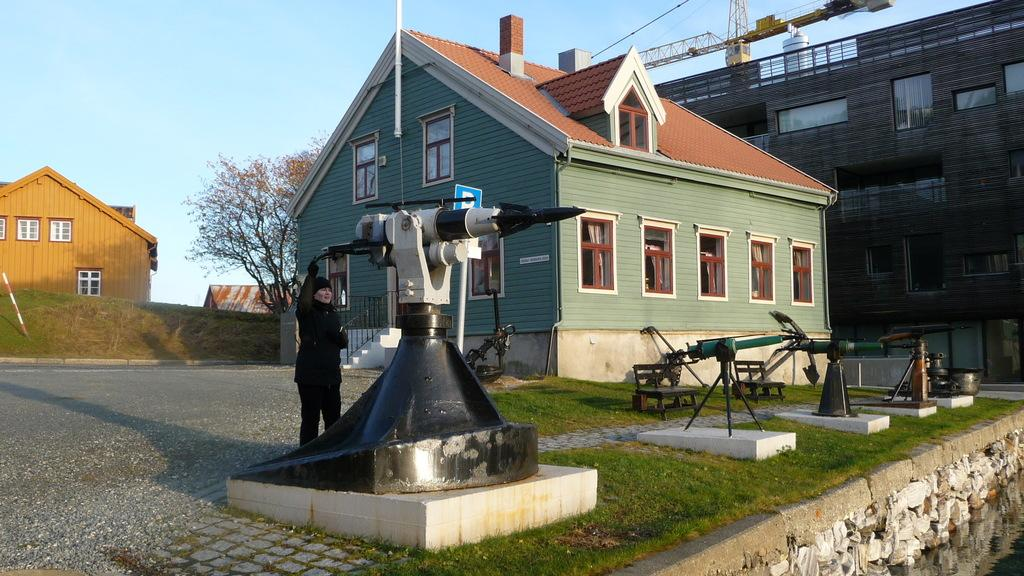Who is present in the image? There is a woman in the image. What objects can be seen in the image? There are telescopes in the image. What type of structures are visible in the image? There are buildings in the image. What can be seen in the background of the image? There is a tree and a crane in the background of the image. How many dogs are present in the image? There are no dogs present in the image. What scientific discoveries are being made in the image? The image does not depict any scientific discoveries; it features a woman, telescopes, buildings, a tree, and a crane. 